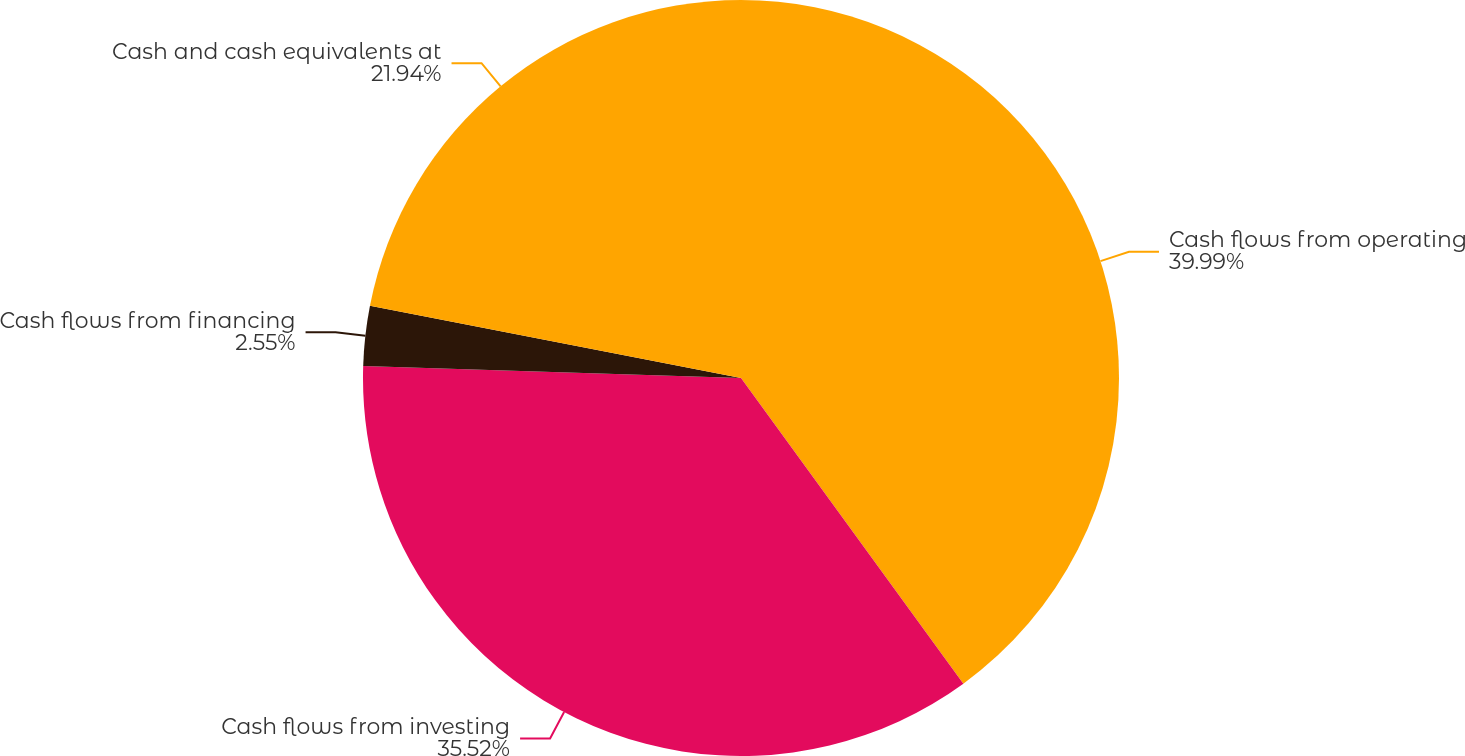Convert chart. <chart><loc_0><loc_0><loc_500><loc_500><pie_chart><fcel>Cash flows from operating<fcel>Cash flows from investing<fcel>Cash flows from financing<fcel>Cash and cash equivalents at<nl><fcel>39.99%<fcel>35.52%<fcel>2.55%<fcel>21.94%<nl></chart> 